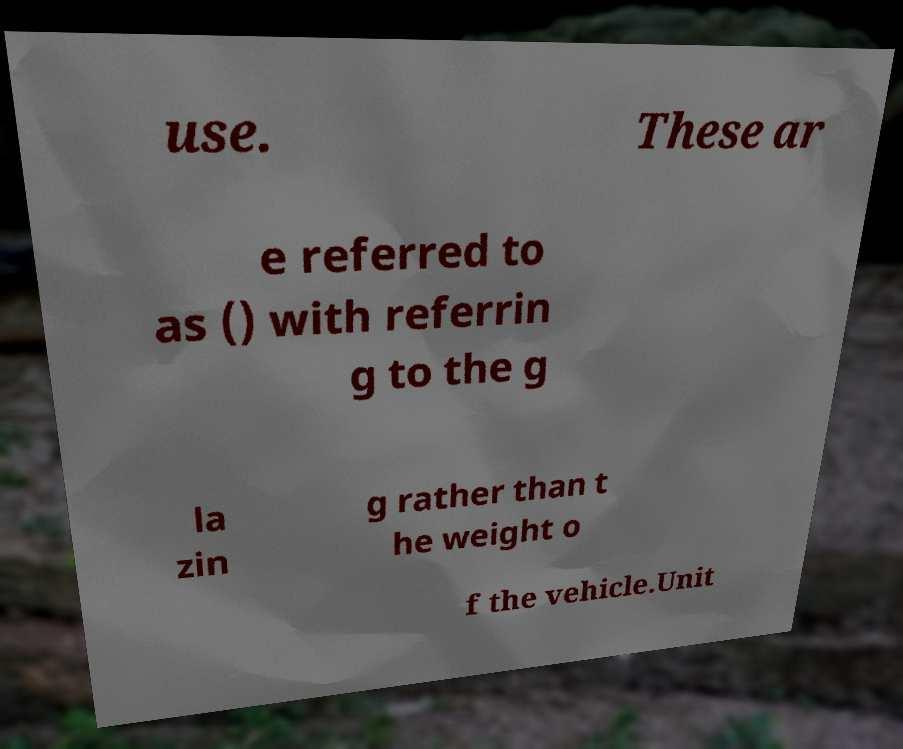Could you extract and type out the text from this image? use. These ar e referred to as () with referrin g to the g la zin g rather than t he weight o f the vehicle.Unit 